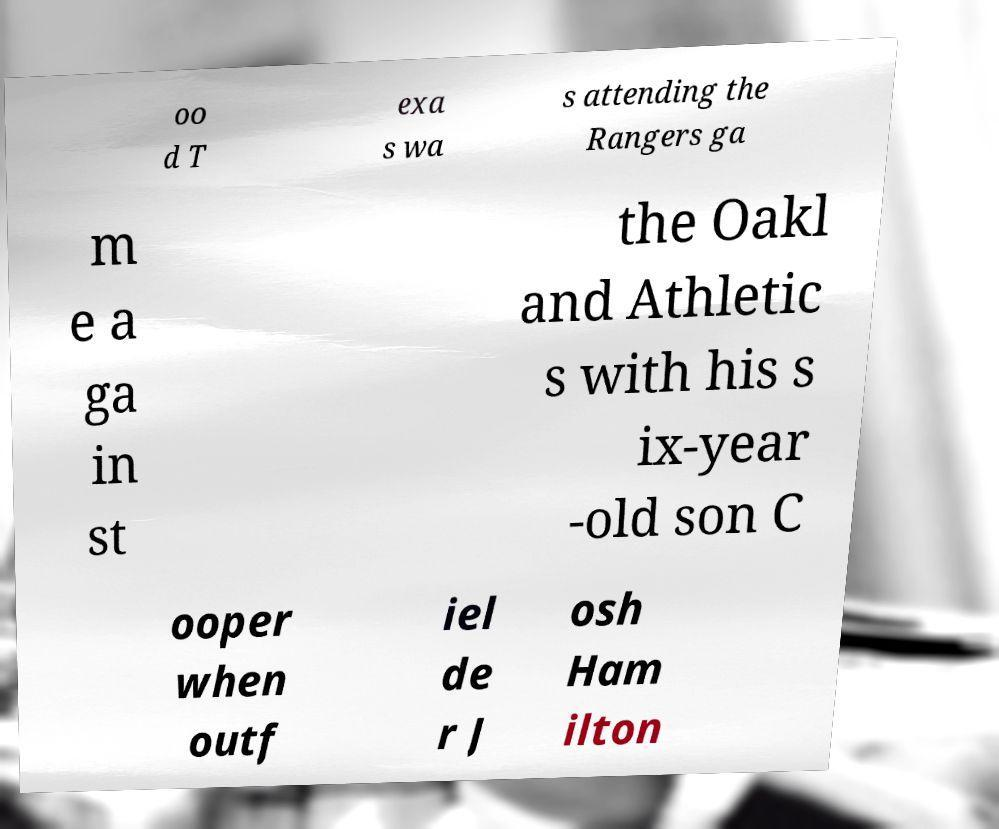Please read and relay the text visible in this image. What does it say? oo d T exa s wa s attending the Rangers ga m e a ga in st the Oakl and Athletic s with his s ix-year -old son C ooper when outf iel de r J osh Ham ilton 